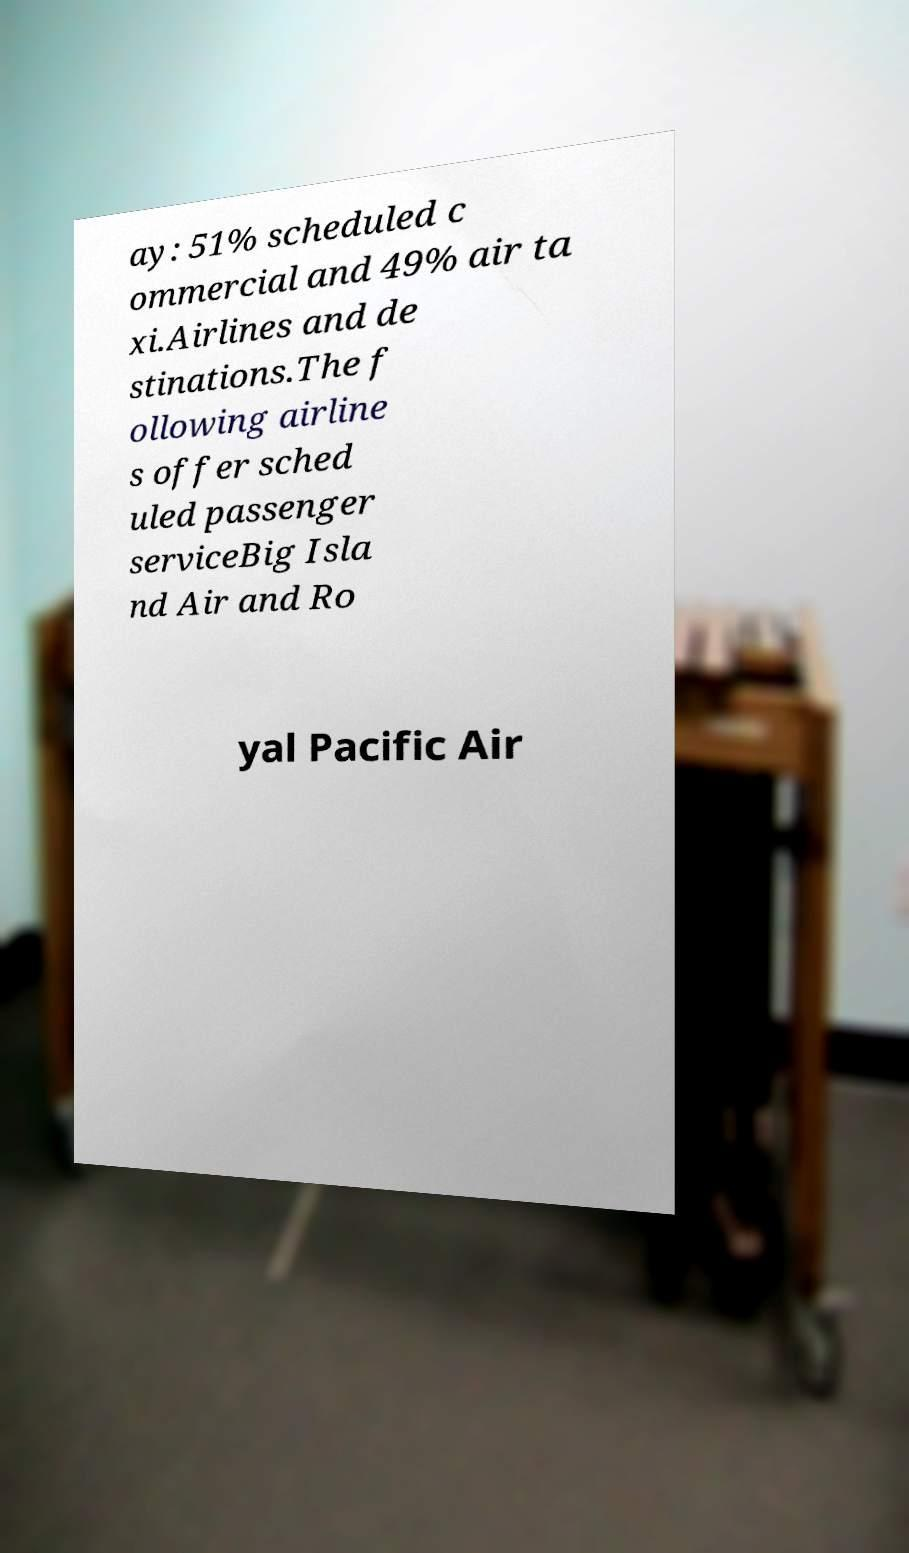Can you accurately transcribe the text from the provided image for me? ay: 51% scheduled c ommercial and 49% air ta xi.Airlines and de stinations.The f ollowing airline s offer sched uled passenger serviceBig Isla nd Air and Ro yal Pacific Air 